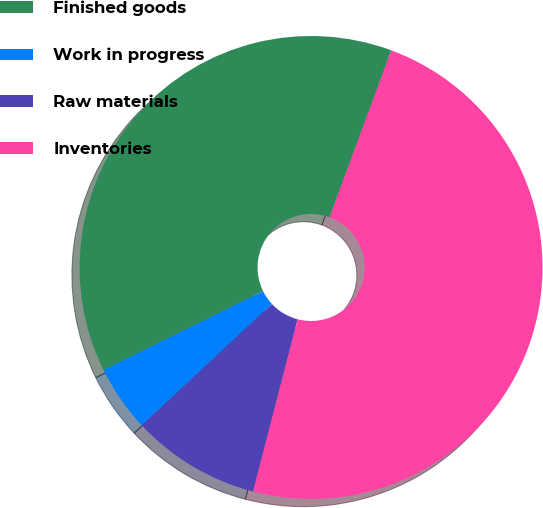Convert chart. <chart><loc_0><loc_0><loc_500><loc_500><pie_chart><fcel>Finished goods<fcel>Work in progress<fcel>Raw materials<fcel>Inventories<nl><fcel>37.94%<fcel>4.65%<fcel>9.02%<fcel>48.39%<nl></chart> 